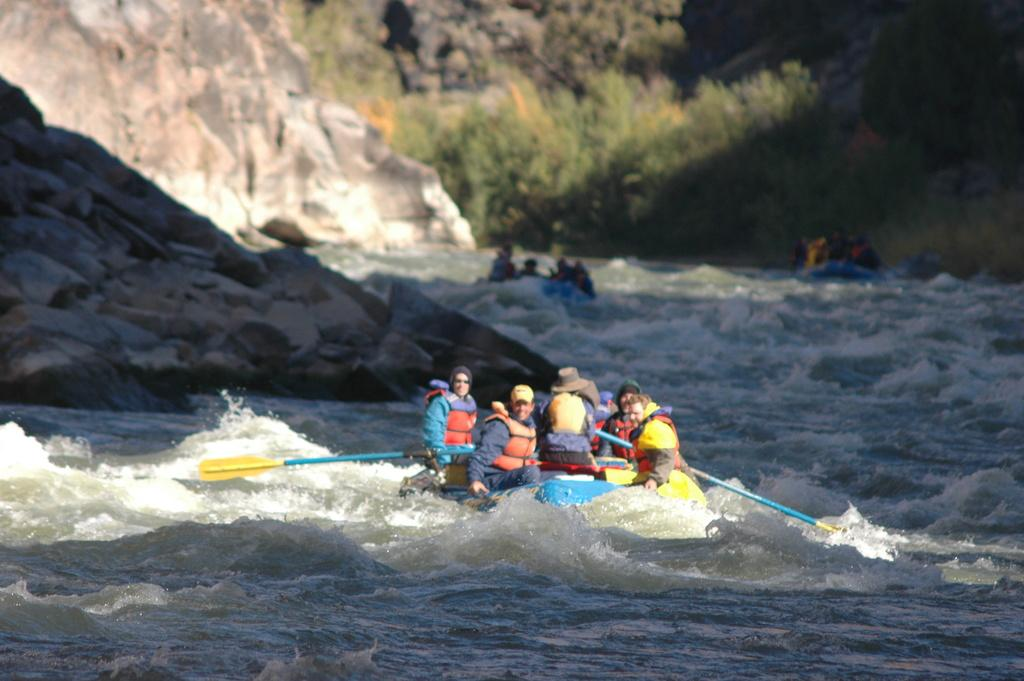How many boats are in the image? There are three boats in the image. What is happening on one of the boats? There is a group of people sitting on one of the boats. Where are the boats located? The boats are on the water. What can be seen in the background of the image? There are trees and a rock visible in the background of the image. What is the color of the trees in the image? The trees are green in color. What type of ornament is hanging from the trees in the image? There are no ornaments hanging from the trees in the image; only the trees and a rock are visible in the background. 